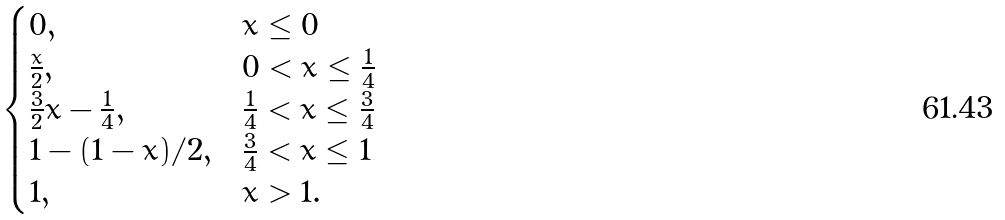Convert formula to latex. <formula><loc_0><loc_0><loc_500><loc_500>\begin{cases} 0 , & x \leq 0 \\ \frac { x } { 2 } , & 0 < x \leq \frac { 1 } { 4 } \\ \frac { 3 } { 2 } x - \frac { 1 } { 4 } , & \frac { 1 } { 4 } < x \leq \frac { 3 } { 4 } \\ 1 - ( 1 - x ) / 2 , & \frac { 3 } { 4 } < x \leq 1 \\ 1 , & x > 1 . \end{cases}</formula> 